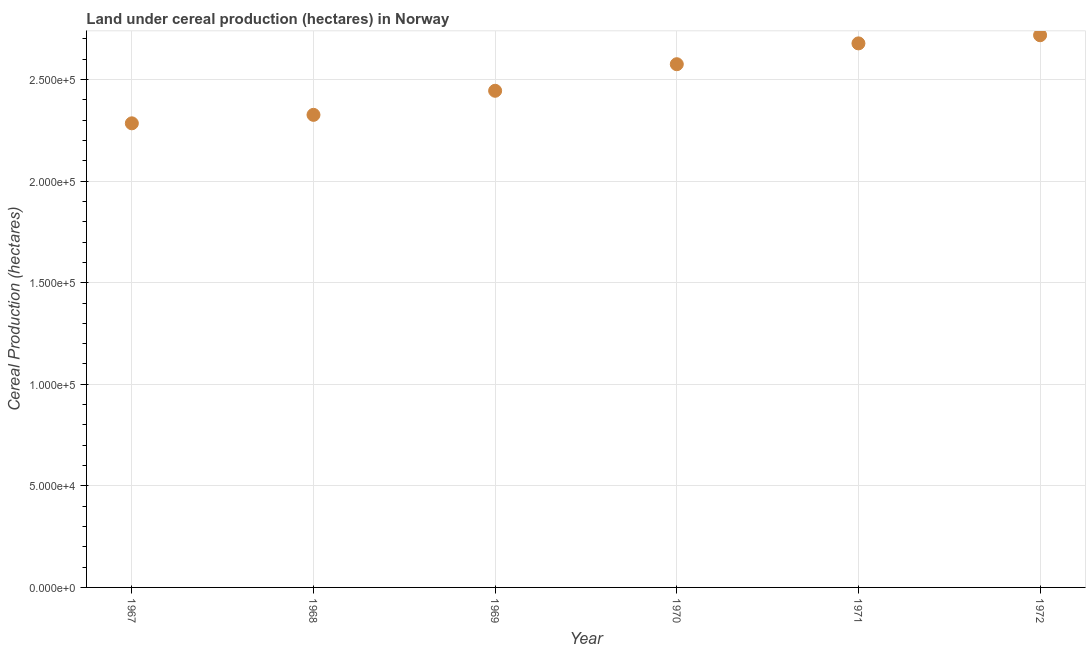What is the land under cereal production in 1971?
Provide a succinct answer. 2.68e+05. Across all years, what is the maximum land under cereal production?
Your response must be concise. 2.72e+05. Across all years, what is the minimum land under cereal production?
Offer a very short reply. 2.28e+05. In which year was the land under cereal production minimum?
Provide a short and direct response. 1967. What is the sum of the land under cereal production?
Make the answer very short. 1.50e+06. What is the difference between the land under cereal production in 1971 and 1972?
Offer a terse response. -4017. What is the average land under cereal production per year?
Your answer should be compact. 2.50e+05. What is the median land under cereal production?
Offer a terse response. 2.51e+05. In how many years, is the land under cereal production greater than 10000 hectares?
Your answer should be compact. 6. Do a majority of the years between 1969 and 1968 (inclusive) have land under cereal production greater than 260000 hectares?
Make the answer very short. No. What is the ratio of the land under cereal production in 1968 to that in 1969?
Your answer should be compact. 0.95. What is the difference between the highest and the second highest land under cereal production?
Your answer should be compact. 4017. What is the difference between the highest and the lowest land under cereal production?
Your answer should be very brief. 4.34e+04. Does the land under cereal production monotonically increase over the years?
Your answer should be very brief. Yes. How many dotlines are there?
Offer a terse response. 1. What is the difference between two consecutive major ticks on the Y-axis?
Your answer should be very brief. 5.00e+04. Are the values on the major ticks of Y-axis written in scientific E-notation?
Keep it short and to the point. Yes. Does the graph contain any zero values?
Give a very brief answer. No. Does the graph contain grids?
Offer a very short reply. Yes. What is the title of the graph?
Provide a short and direct response. Land under cereal production (hectares) in Norway. What is the label or title of the X-axis?
Your answer should be very brief. Year. What is the label or title of the Y-axis?
Offer a terse response. Cereal Production (hectares). What is the Cereal Production (hectares) in 1967?
Your response must be concise. 2.28e+05. What is the Cereal Production (hectares) in 1968?
Give a very brief answer. 2.33e+05. What is the Cereal Production (hectares) in 1969?
Provide a succinct answer. 2.44e+05. What is the Cereal Production (hectares) in 1970?
Provide a succinct answer. 2.58e+05. What is the Cereal Production (hectares) in 1971?
Make the answer very short. 2.68e+05. What is the Cereal Production (hectares) in 1972?
Make the answer very short. 2.72e+05. What is the difference between the Cereal Production (hectares) in 1967 and 1968?
Offer a very short reply. -4167. What is the difference between the Cereal Production (hectares) in 1967 and 1969?
Provide a short and direct response. -1.60e+04. What is the difference between the Cereal Production (hectares) in 1967 and 1970?
Ensure brevity in your answer.  -2.91e+04. What is the difference between the Cereal Production (hectares) in 1967 and 1971?
Your response must be concise. -3.94e+04. What is the difference between the Cereal Production (hectares) in 1967 and 1972?
Your answer should be very brief. -4.34e+04. What is the difference between the Cereal Production (hectares) in 1968 and 1969?
Offer a very short reply. -1.19e+04. What is the difference between the Cereal Production (hectares) in 1968 and 1970?
Offer a terse response. -2.49e+04. What is the difference between the Cereal Production (hectares) in 1968 and 1971?
Your answer should be compact. -3.52e+04. What is the difference between the Cereal Production (hectares) in 1968 and 1972?
Your answer should be very brief. -3.92e+04. What is the difference between the Cereal Production (hectares) in 1969 and 1970?
Keep it short and to the point. -1.31e+04. What is the difference between the Cereal Production (hectares) in 1969 and 1971?
Keep it short and to the point. -2.33e+04. What is the difference between the Cereal Production (hectares) in 1969 and 1972?
Give a very brief answer. -2.73e+04. What is the difference between the Cereal Production (hectares) in 1970 and 1971?
Keep it short and to the point. -1.03e+04. What is the difference between the Cereal Production (hectares) in 1970 and 1972?
Give a very brief answer. -1.43e+04. What is the difference between the Cereal Production (hectares) in 1971 and 1972?
Keep it short and to the point. -4017. What is the ratio of the Cereal Production (hectares) in 1967 to that in 1969?
Your answer should be very brief. 0.93. What is the ratio of the Cereal Production (hectares) in 1967 to that in 1970?
Your answer should be compact. 0.89. What is the ratio of the Cereal Production (hectares) in 1967 to that in 1971?
Offer a terse response. 0.85. What is the ratio of the Cereal Production (hectares) in 1967 to that in 1972?
Keep it short and to the point. 0.84. What is the ratio of the Cereal Production (hectares) in 1968 to that in 1969?
Provide a short and direct response. 0.95. What is the ratio of the Cereal Production (hectares) in 1968 to that in 1970?
Keep it short and to the point. 0.9. What is the ratio of the Cereal Production (hectares) in 1968 to that in 1971?
Your answer should be compact. 0.87. What is the ratio of the Cereal Production (hectares) in 1968 to that in 1972?
Your response must be concise. 0.86. What is the ratio of the Cereal Production (hectares) in 1969 to that in 1970?
Offer a terse response. 0.95. What is the ratio of the Cereal Production (hectares) in 1969 to that in 1971?
Your answer should be compact. 0.91. What is the ratio of the Cereal Production (hectares) in 1969 to that in 1972?
Your answer should be compact. 0.9. What is the ratio of the Cereal Production (hectares) in 1970 to that in 1971?
Provide a succinct answer. 0.96. What is the ratio of the Cereal Production (hectares) in 1970 to that in 1972?
Provide a succinct answer. 0.95. 